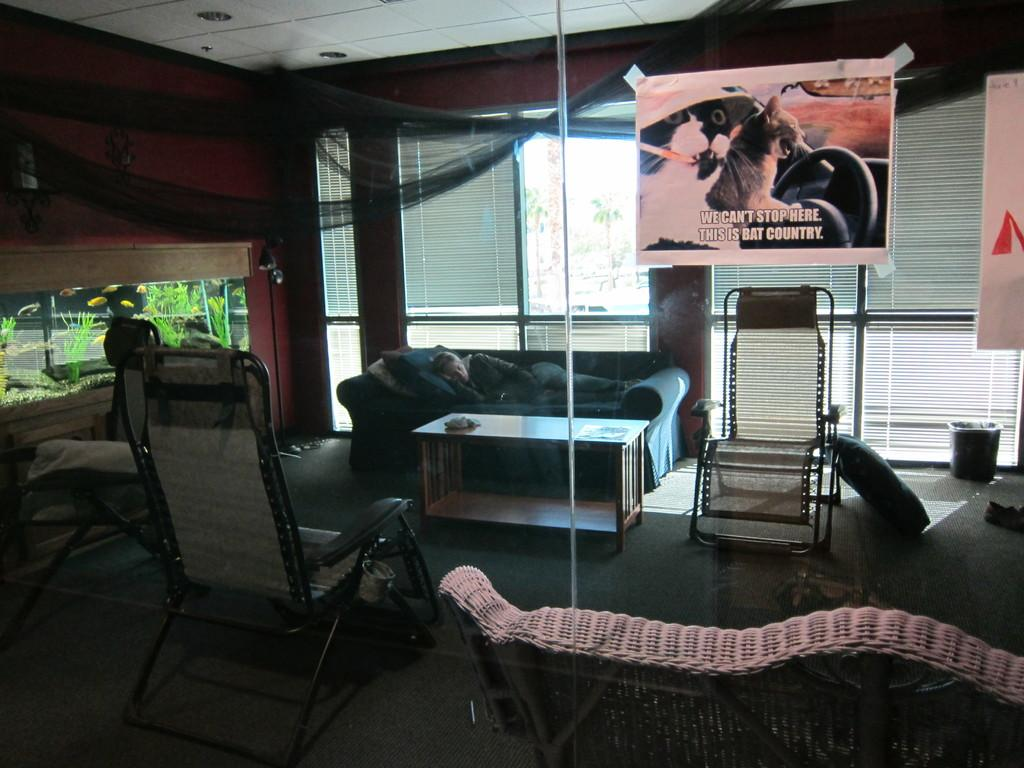What type of space is depicted in the image? There is a room in the image. What furniture is present in the room? There are chairs and a sofa in the room. What is the person in the image doing? A person is sleeping on the sofa. What other objects can be seen in the room? There is a table, a bin, banners, windows, a pole, and an aquarium in the room. What might be on the table in the room? There are items on the table in the room. How many horses are visible in the image? There are no horses present in the image. What type of pump is used to inflate the banners in the image? There is no pump visible in the image, and the banners do not appear to be inflated. 